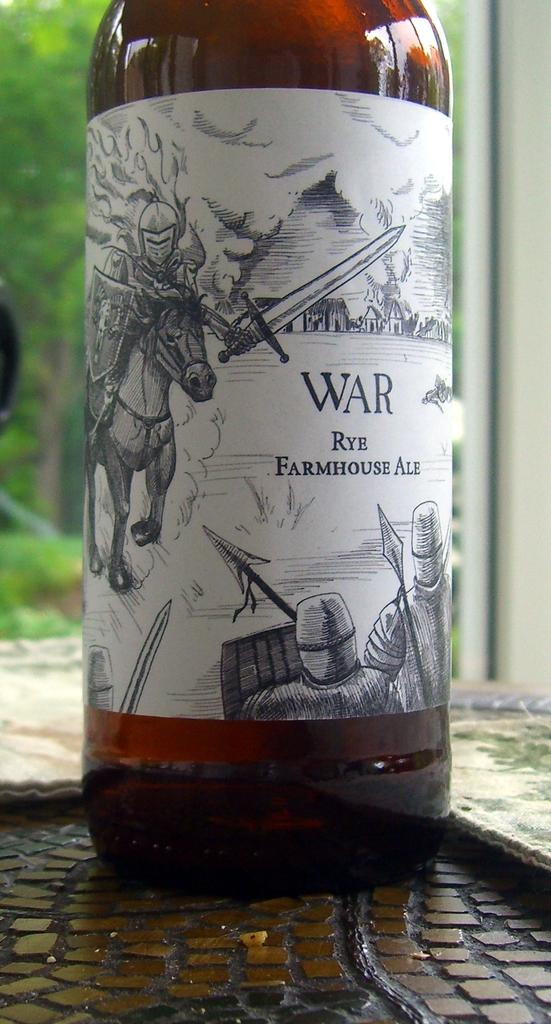<image>
Provide a brief description of the given image. War beer bottle in front of a green background. 